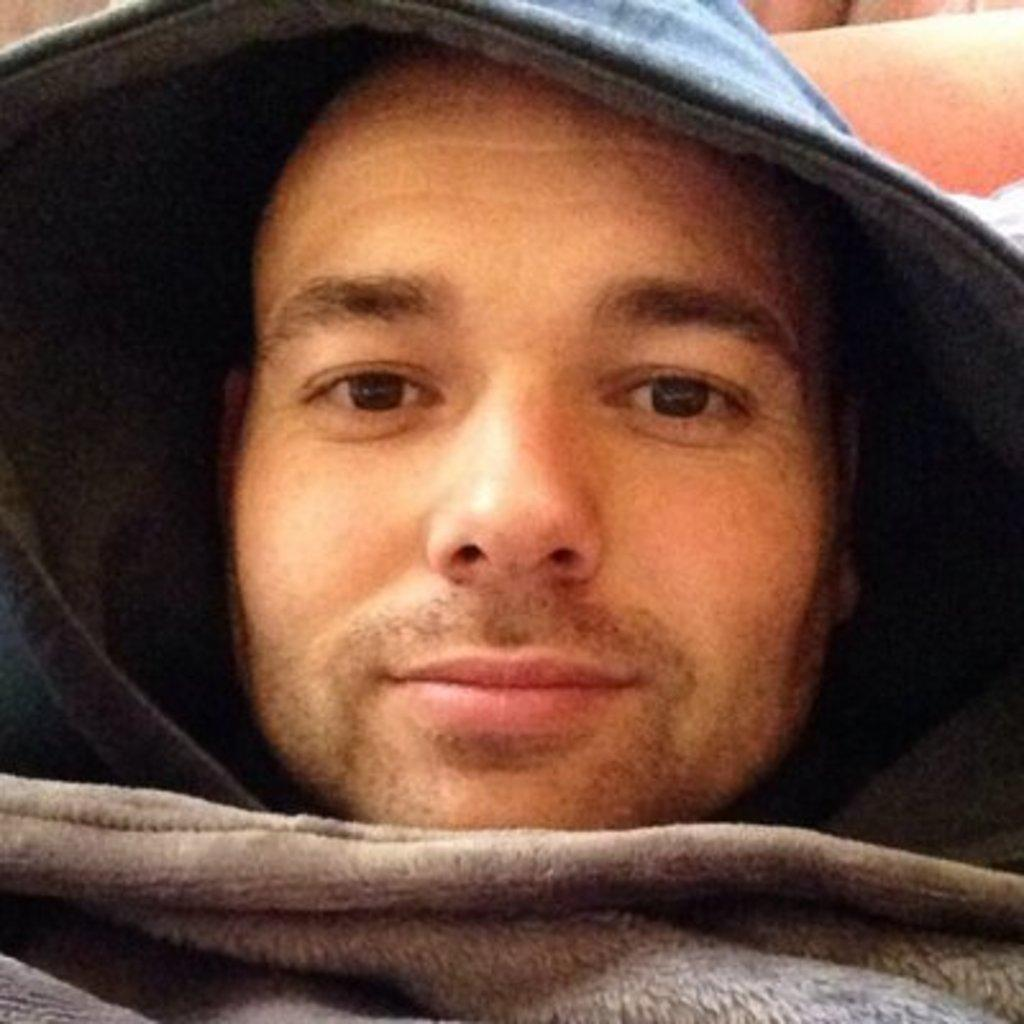Who or what is present in the image? There is a person in the image. What is the person wearing? The person is wearing a hoodie. What else can be seen in the image besides the person? There is a blanket in the image. What type of apparatus is being used by the person in the image? There is no apparatus visible in the image; it only shows a person wearing a hoodie and a blanket. Where is the house located in the image? There is no house present in the image. 